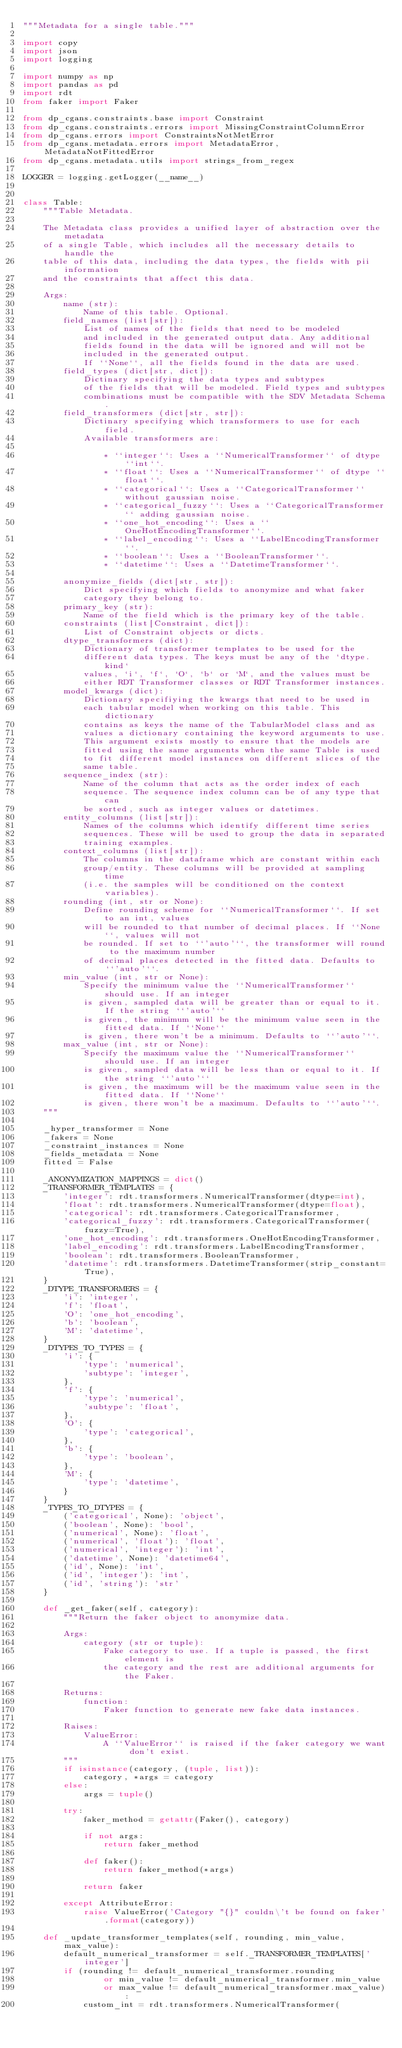<code> <loc_0><loc_0><loc_500><loc_500><_Python_>"""Metadata for a single table."""

import copy
import json
import logging

import numpy as np
import pandas as pd
import rdt
from faker import Faker

from dp_cgans.constraints.base import Constraint
from dp_cgans.constraints.errors import MissingConstraintColumnError
from dp_cgans.errors import ConstraintsNotMetError
from dp_cgans.metadata.errors import MetadataError, MetadataNotFittedError
from dp_cgans.metadata.utils import strings_from_regex

LOGGER = logging.getLogger(__name__)


class Table:
    """Table Metadata.

    The Metadata class provides a unified layer of abstraction over the metadata
    of a single Table, which includes all the necessary details to handle the
    table of this data, including the data types, the fields with pii information
    and the constraints that affect this data.

    Args:
        name (str):
            Name of this table. Optional.
        field_names (list[str]):
            List of names of the fields that need to be modeled
            and included in the generated output data. Any additional
            fields found in the data will be ignored and will not be
            included in the generated output.
            If ``None``, all the fields found in the data are used.
        field_types (dict[str, dict]):
            Dictinary specifying the data types and subtypes
            of the fields that will be modeled. Field types and subtypes
            combinations must be compatible with the SDV Metadata Schema.
        field_transformers (dict[str, str]):
            Dictinary specifying which transformers to use for each field.
            Available transformers are:

                * ``integer``: Uses a ``NumericalTransformer`` of dtype ``int``.
                * ``float``: Uses a ``NumericalTransformer`` of dtype ``float``.
                * ``categorical``: Uses a ``CategoricalTransformer`` without gaussian noise.
                * ``categorical_fuzzy``: Uses a ``CategoricalTransformer`` adding gaussian noise.
                * ``one_hot_encoding``: Uses a ``OneHotEncodingTransformer``.
                * ``label_encoding``: Uses a ``LabelEncodingTransformer``.
                * ``boolean``: Uses a ``BooleanTransformer``.
                * ``datetime``: Uses a ``DatetimeTransformer``.

        anonymize_fields (dict[str, str]):
            Dict specifying which fields to anonymize and what faker
            category they belong to.
        primary_key (str):
            Name of the field which is the primary key of the table.
        constraints (list[Constraint, dict]):
            List of Constraint objects or dicts.
        dtype_transformers (dict):
            Dictionary of transformer templates to be used for the
            different data types. The keys must be any of the `dtype.kind`
            values, `i`, `f`, `O`, `b` or `M`, and the values must be
            either RDT Transformer classes or RDT Transformer instances.
        model_kwargs (dict):
            Dictionary specifiying the kwargs that need to be used in
            each tabular model when working on this table. This dictionary
            contains as keys the name of the TabularModel class and as
            values a dictionary containing the keyword arguments to use.
            This argument exists mostly to ensure that the models are
            fitted using the same arguments when the same Table is used
            to fit different model instances on different slices of the
            same table.
        sequence_index (str):
            Name of the column that acts as the order index of each
            sequence. The sequence index column can be of any type that can
            be sorted, such as integer values or datetimes.
        entity_columns (list[str]):
            Names of the columns which identify different time series
            sequences. These will be used to group the data in separated
            training examples.
        context_columns (list[str]):
            The columns in the dataframe which are constant within each
            group/entity. These columns will be provided at sampling time
            (i.e. the samples will be conditioned on the context variables).
        rounding (int, str or None):
            Define rounding scheme for ``NumericalTransformer``. If set to an int, values
            will be rounded to that number of decimal places. If ``None``, values will not
            be rounded. If set to ``'auto'``, the transformer will round to the maximum number
            of decimal places detected in the fitted data. Defaults to ``'auto'``.
        min_value (int, str or None):
            Specify the minimum value the ``NumericalTransformer`` should use. If an integer
            is given, sampled data will be greater than or equal to it. If the string ``'auto'``
            is given, the minimum will be the minimum value seen in the fitted data. If ``None``
            is given, there won't be a minimum. Defaults to ``'auto'``.
        max_value (int, str or None):
            Specify the maximum value the ``NumericalTransformer`` should use. If an integer
            is given, sampled data will be less than or equal to it. If the string ``'auto'``
            is given, the maximum will be the maximum value seen in the fitted data. If ``None``
            is given, there won't be a maximum. Defaults to ``'auto'``.
    """

    _hyper_transformer = None
    _fakers = None
    _constraint_instances = None
    _fields_metadata = None
    fitted = False

    _ANONYMIZATION_MAPPINGS = dict()
    _TRANSFORMER_TEMPLATES = {
        'integer': rdt.transformers.NumericalTransformer(dtype=int),
        'float': rdt.transformers.NumericalTransformer(dtype=float),
        'categorical': rdt.transformers.CategoricalTransformer,
        'categorical_fuzzy': rdt.transformers.CategoricalTransformer(fuzzy=True),
        'one_hot_encoding': rdt.transformers.OneHotEncodingTransformer,
        'label_encoding': rdt.transformers.LabelEncodingTransformer,
        'boolean': rdt.transformers.BooleanTransformer,
        'datetime': rdt.transformers.DatetimeTransformer(strip_constant=True),
    }
    _DTYPE_TRANSFORMERS = {
        'i': 'integer',
        'f': 'float',
        'O': 'one_hot_encoding',
        'b': 'boolean',
        'M': 'datetime',
    }
    _DTYPES_TO_TYPES = {
        'i': {
            'type': 'numerical',
            'subtype': 'integer',
        },
        'f': {
            'type': 'numerical',
            'subtype': 'float',
        },
        'O': {
            'type': 'categorical',
        },
        'b': {
            'type': 'boolean',
        },
        'M': {
            'type': 'datetime',
        }
    }
    _TYPES_TO_DTYPES = {
        ('categorical', None): 'object',
        ('boolean', None): 'bool',
        ('numerical', None): 'float',
        ('numerical', 'float'): 'float',
        ('numerical', 'integer'): 'int',
        ('datetime', None): 'datetime64',
        ('id', None): 'int',
        ('id', 'integer'): 'int',
        ('id', 'string'): 'str'
    }

    def _get_faker(self, category):
        """Return the faker object to anonymize data.

        Args:
            category (str or tuple):
                Fake category to use. If a tuple is passed, the first element is
                the category and the rest are additional arguments for the Faker.

        Returns:
            function:
                Faker function to generate new fake data instances.

        Raises:
            ValueError:
                A ``ValueError`` is raised if the faker category we want don't exist.
        """
        if isinstance(category, (tuple, list)):
            category, *args = category
        else:
            args = tuple()

        try:
            faker_method = getattr(Faker(), category)

            if not args:
                return faker_method

            def faker():
                return faker_method(*args)

            return faker

        except AttributeError:
            raise ValueError('Category "{}" couldn\'t be found on faker'.format(category))

    def _update_transformer_templates(self, rounding, min_value, max_value):
        default_numerical_transformer = self._TRANSFORMER_TEMPLATES['integer']
        if (rounding != default_numerical_transformer.rounding
                or min_value != default_numerical_transformer.min_value
                or max_value != default_numerical_transformer.max_value):
            custom_int = rdt.transformers.NumericalTransformer(</code> 